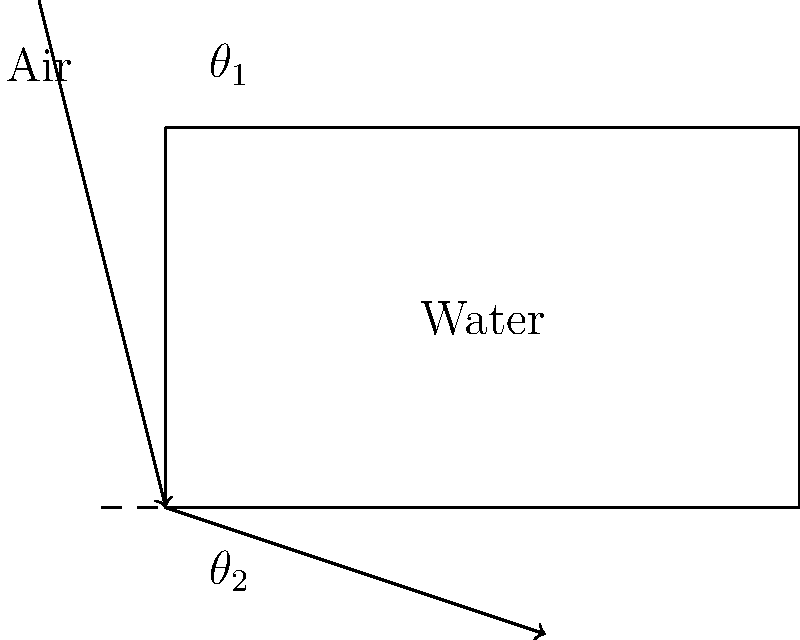Your child is learning about light refraction in their ETM-LA Physics class. They show you a diagram of light passing from air into water. If the angle of incidence (θ₁) in air is 45°, and the refractive index of air is 1.00 while the refractive index of water is 1.33, what is the angle of refraction (θ₂) in water? Let's approach this step-by-step using Snell's Law:

1) Snell's Law states: $n_1 \sin(\theta_1) = n_2 \sin(\theta_2)$

   Where:
   $n_1$ is the refractive index of the first medium (air)
   $n_2$ is the refractive index of the second medium (water)
   $\theta_1$ is the angle of incidence
   $\theta_2$ is the angle of refraction

2) We know:
   $n_1 = 1.00$ (air)
   $n_2 = 1.33$ (water)
   $\theta_1 = 45°$

3) Let's substitute these values into Snell's Law:

   $1.00 \sin(45°) = 1.33 \sin(\theta_2)$

4) Simplify the left side:
   $\sin(45°) = \frac{\sqrt{2}}{2} \approx 0.7071$

   So our equation becomes:
   $0.7071 = 1.33 \sin(\theta_2)$

5) Solve for $\theta_2$:
   $\sin(\theta_2) = \frac{0.7071}{1.33} \approx 0.5317$

6) To get $\theta_2$, we need to take the inverse sine (arcsin):

   $\theta_2 = \arcsin(0.5317) \approx 32.0°$

Therefore, the angle of refraction in water is approximately 32.0°.
Answer: 32.0° 